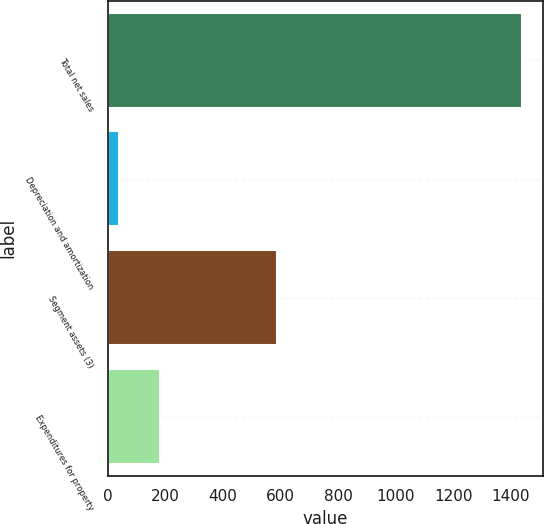<chart> <loc_0><loc_0><loc_500><loc_500><bar_chart><fcel>Total net sales<fcel>Depreciation and amortization<fcel>Segment assets (3)<fcel>Expenditures for property<nl><fcel>1441<fcel>39<fcel>587<fcel>179.2<nl></chart> 